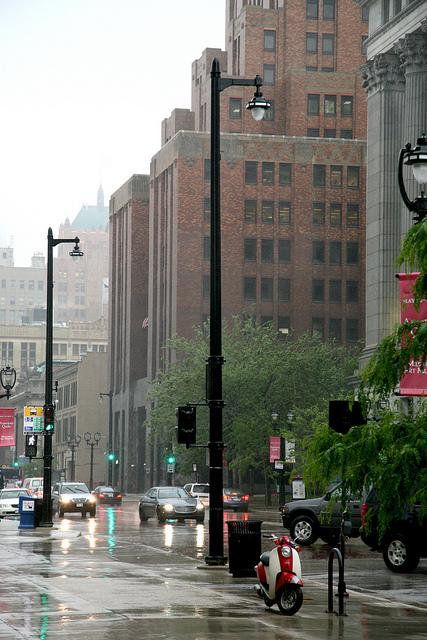What has caused the roads to look reflective?

Choices:
A) ice
B) snow
C) wax
D) rain rain 